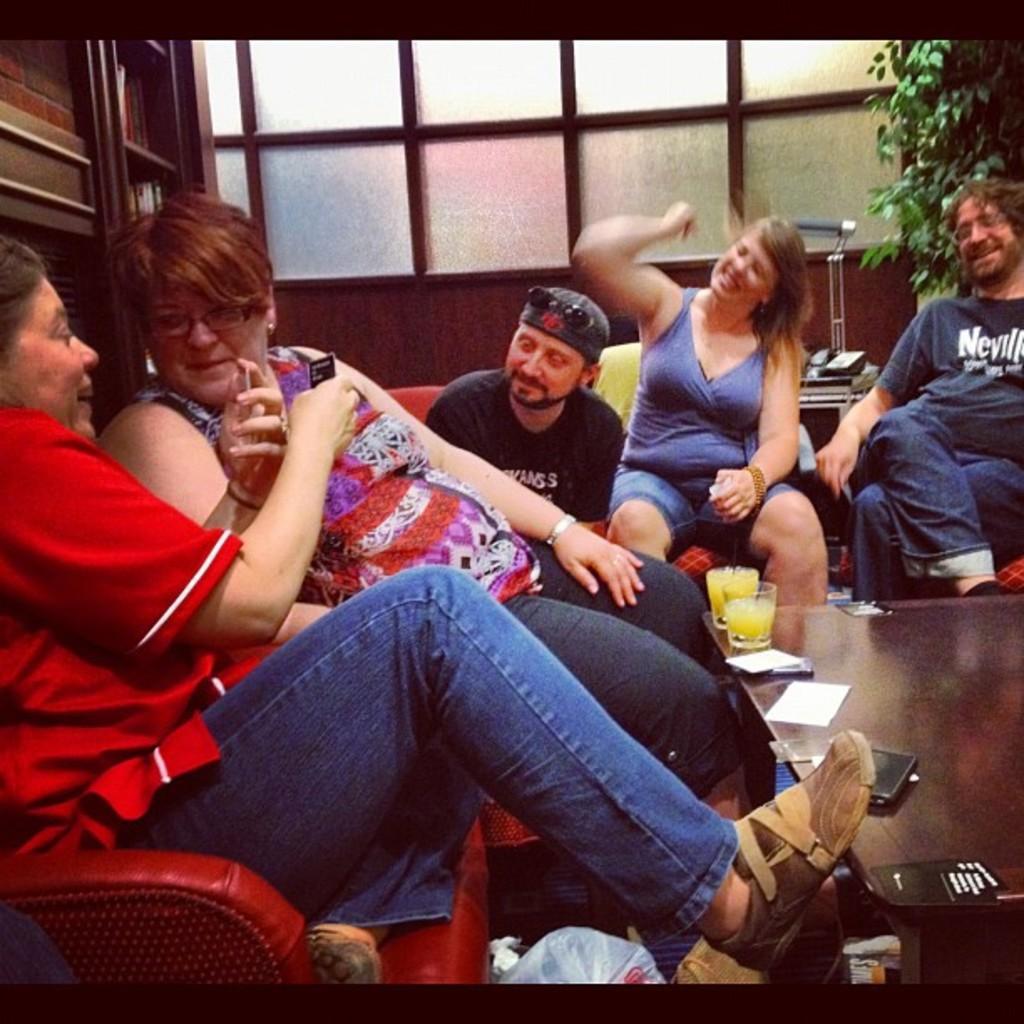Please provide a concise description of this image. We can see few persons are sitting on the chairs at the table and on the table there are glasses with liquid in it, papers and mobiles. In the background there are books on the racks, glass door, plant and objects on a platform. At the bottom there is a bag on the floor. 